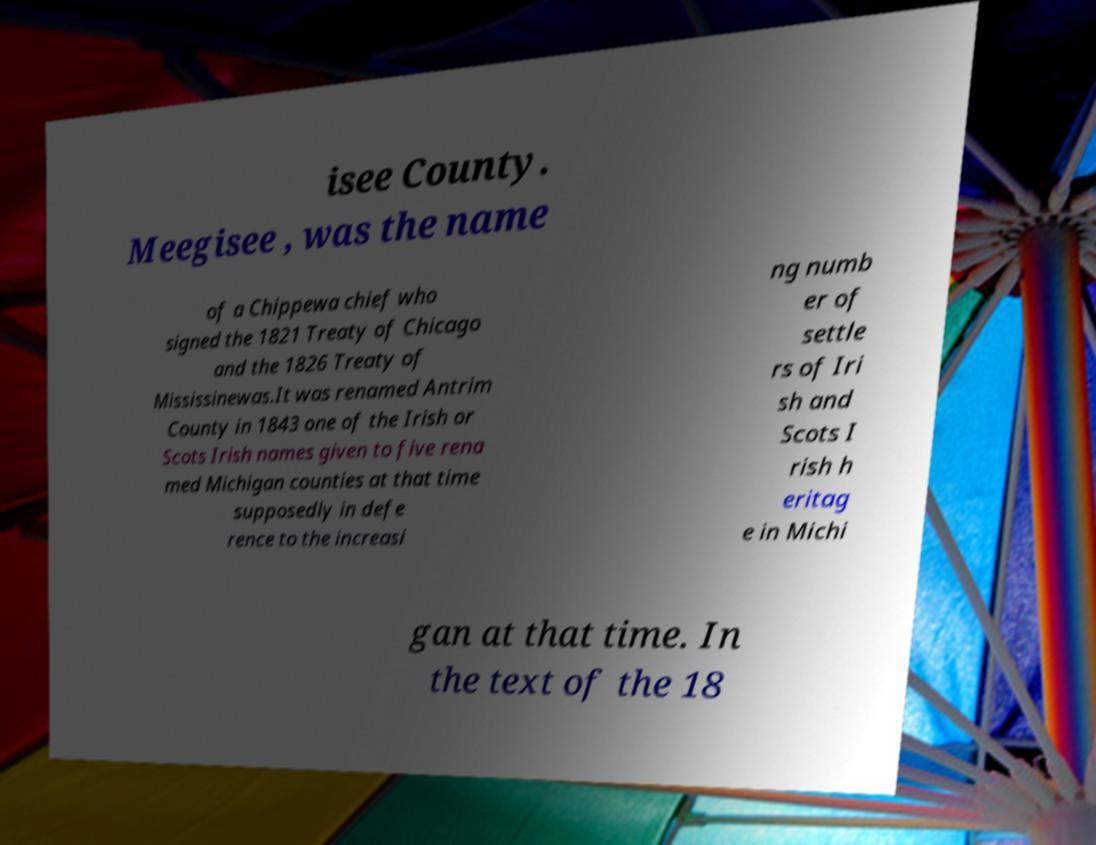What messages or text are displayed in this image? I need them in a readable, typed format. isee County. Meegisee , was the name of a Chippewa chief who signed the 1821 Treaty of Chicago and the 1826 Treaty of Mississinewas.It was renamed Antrim County in 1843 one of the Irish or Scots Irish names given to five rena med Michigan counties at that time supposedly in defe rence to the increasi ng numb er of settle rs of Iri sh and Scots I rish h eritag e in Michi gan at that time. In the text of the 18 